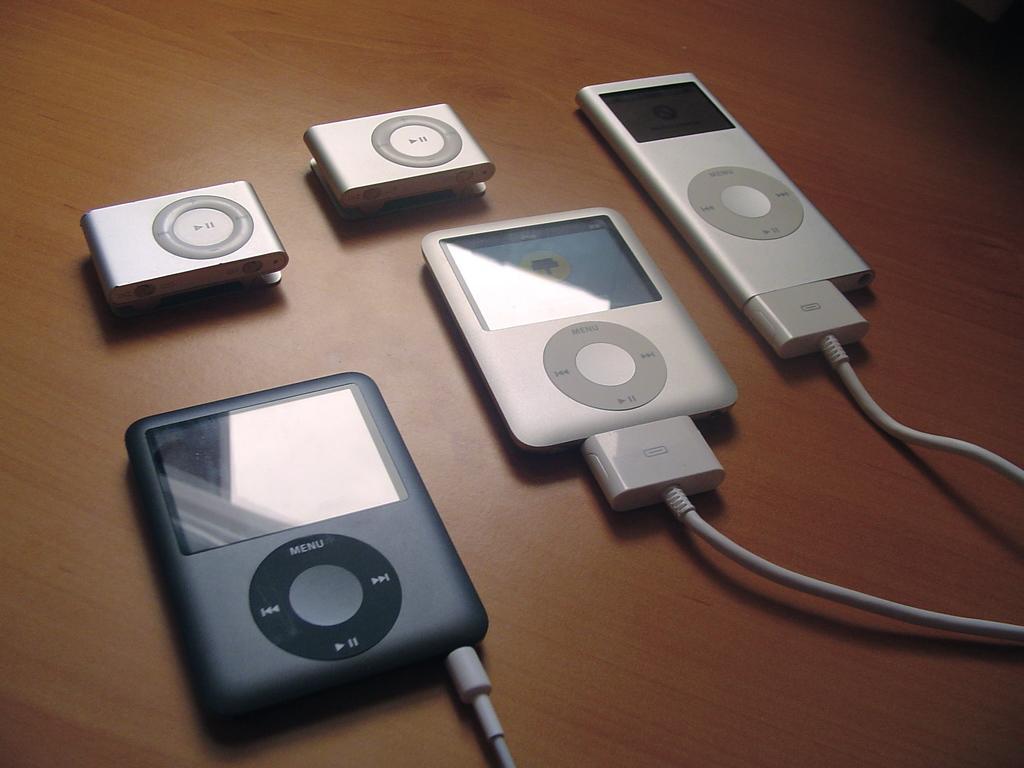Please provide a concise description of this image. In this image in the center there are some electronic devices and wires, at the bottom it looks like a table. 